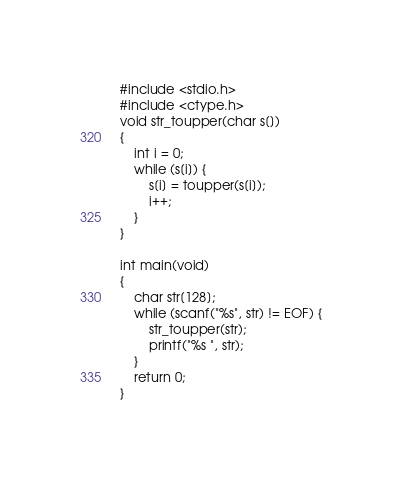<code> <loc_0><loc_0><loc_500><loc_500><_C_>#include <stdio.h>
#include <ctype.h>
void str_toupper(char s[])
{
	int i = 0;
	while (s[i]) {
		s[i] = toupper(s[i]);
		i++;
	}
}

int main(void) 
{
	char str[128];
	while (scanf("%s", str) != EOF) {
		str_toupper(str);
		printf("%s ", str);
	}
	return 0;
}


</code> 